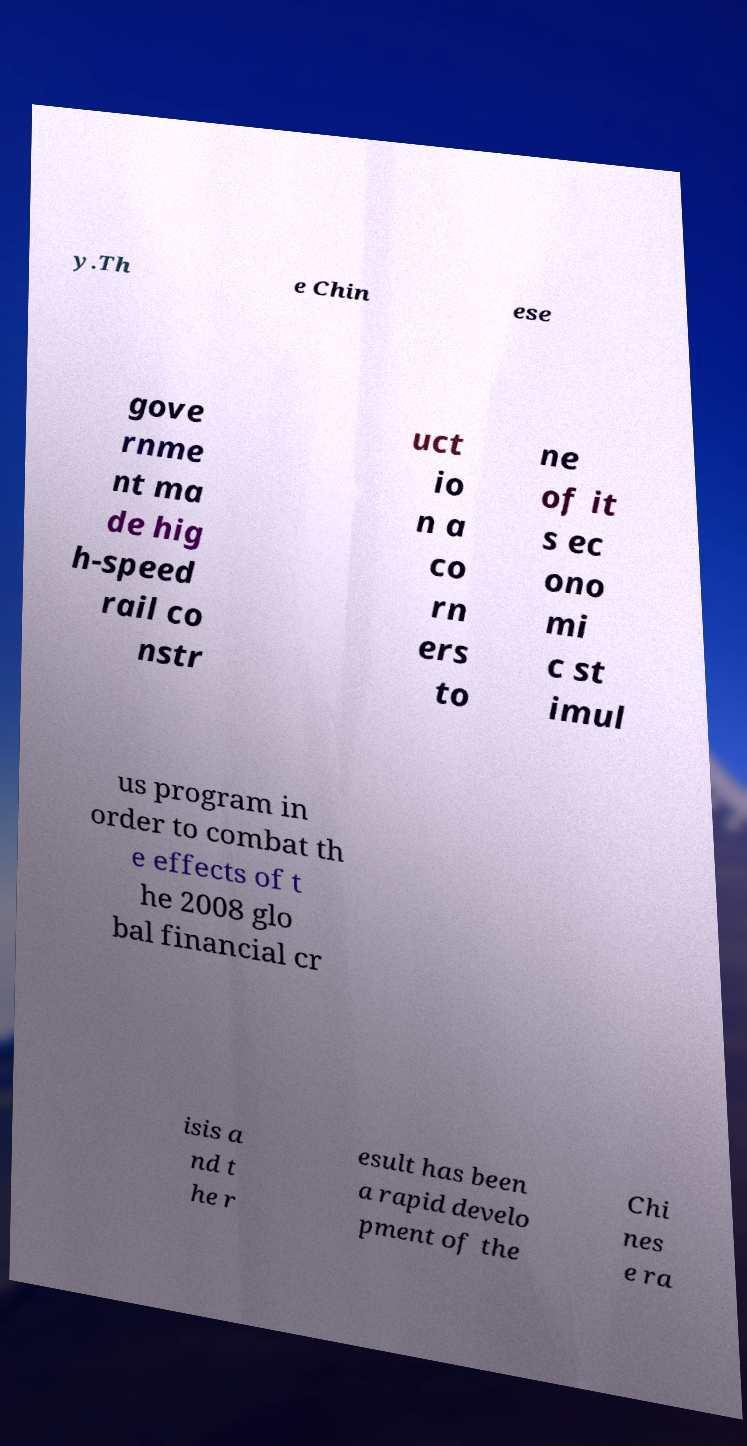Could you assist in decoding the text presented in this image and type it out clearly? y.Th e Chin ese gove rnme nt ma de hig h-speed rail co nstr uct io n a co rn ers to ne of it s ec ono mi c st imul us program in order to combat th e effects of t he 2008 glo bal financial cr isis a nd t he r esult has been a rapid develo pment of the Chi nes e ra 